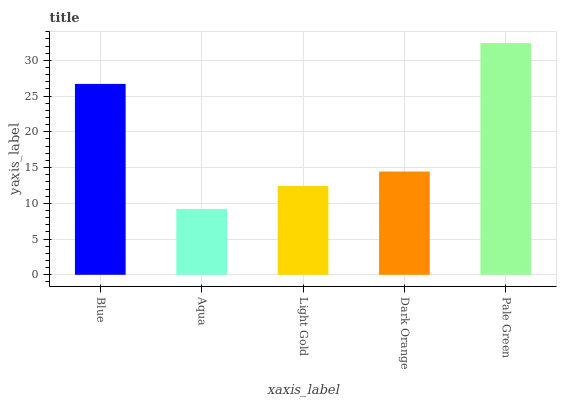Is Aqua the minimum?
Answer yes or no. Yes. Is Pale Green the maximum?
Answer yes or no. Yes. Is Light Gold the minimum?
Answer yes or no. No. Is Light Gold the maximum?
Answer yes or no. No. Is Light Gold greater than Aqua?
Answer yes or no. Yes. Is Aqua less than Light Gold?
Answer yes or no. Yes. Is Aqua greater than Light Gold?
Answer yes or no. No. Is Light Gold less than Aqua?
Answer yes or no. No. Is Dark Orange the high median?
Answer yes or no. Yes. Is Dark Orange the low median?
Answer yes or no. Yes. Is Light Gold the high median?
Answer yes or no. No. Is Pale Green the low median?
Answer yes or no. No. 